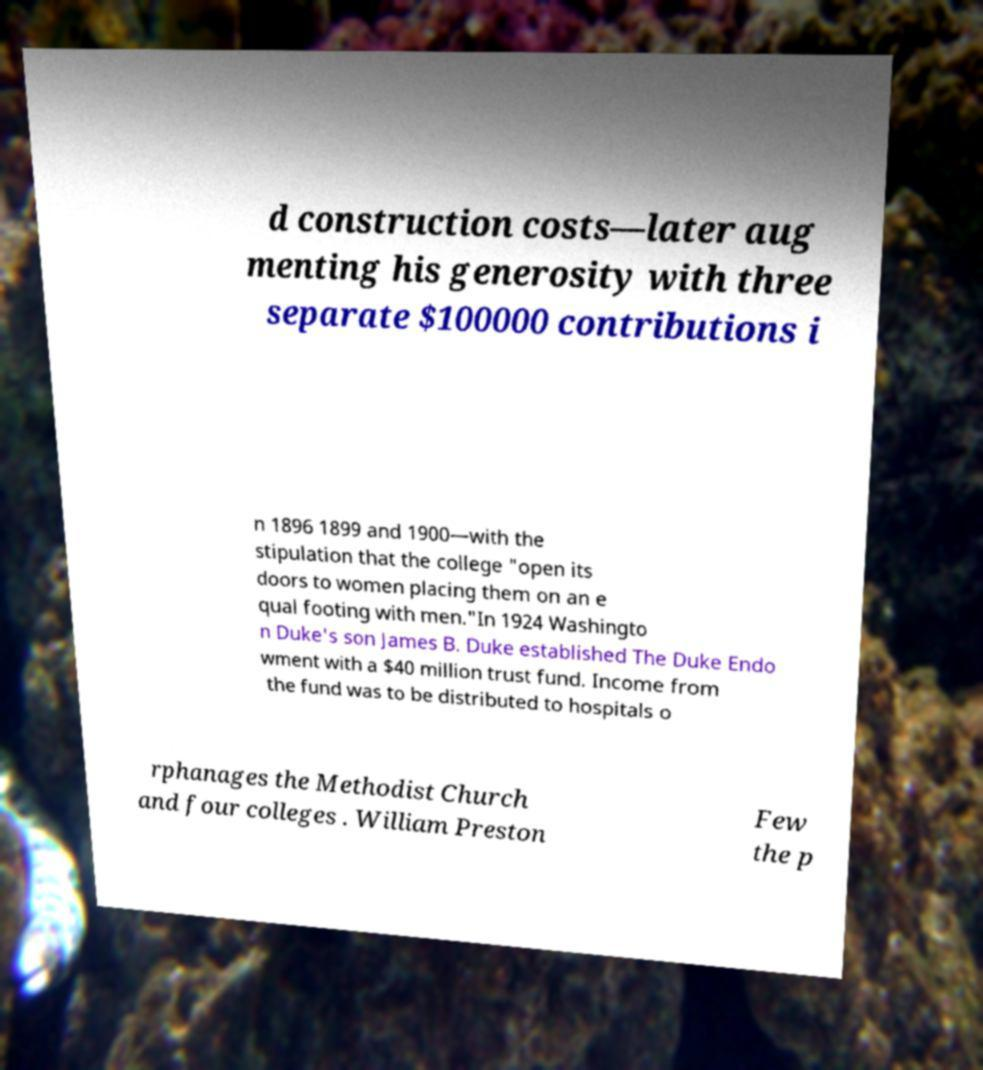Could you assist in decoding the text presented in this image and type it out clearly? d construction costs—later aug menting his generosity with three separate $100000 contributions i n 1896 1899 and 1900—with the stipulation that the college "open its doors to women placing them on an e qual footing with men."In 1924 Washingto n Duke's son James B. Duke established The Duke Endo wment with a $40 million trust fund. Income from the fund was to be distributed to hospitals o rphanages the Methodist Church and four colleges . William Preston Few the p 